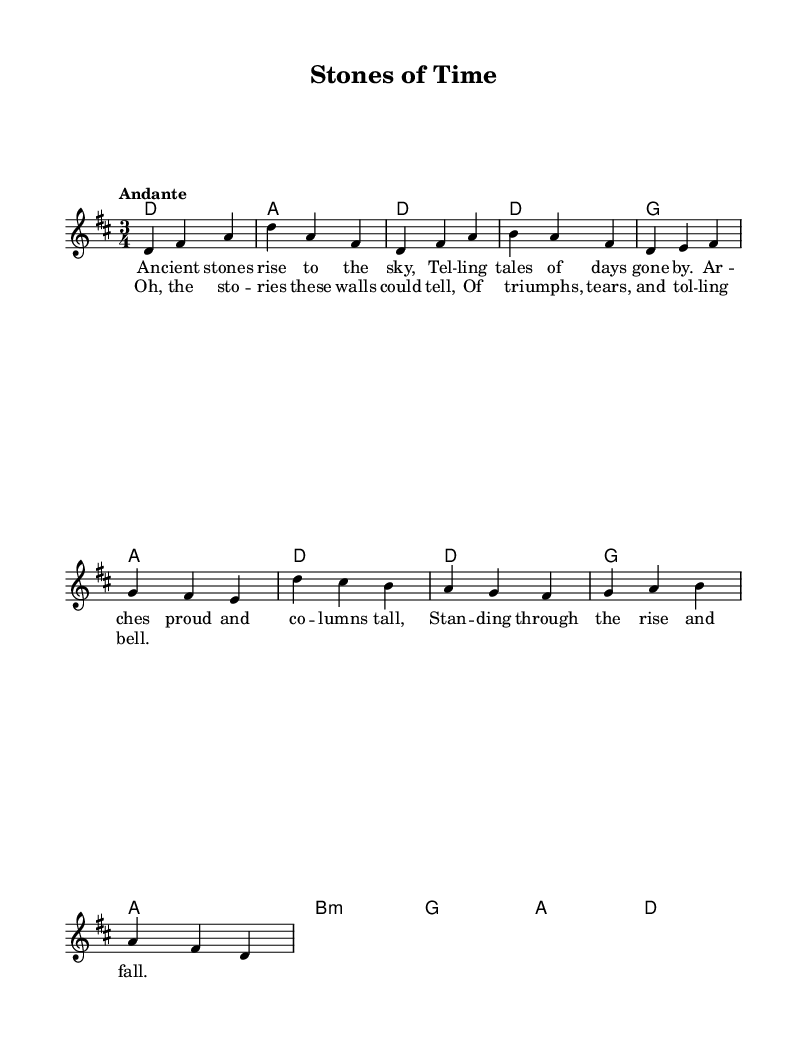What is the key signature of this music? The key signature is D major, which has two sharps (F# and C#). This can be determined by looking at the key signature indicated at the beginning of the staff in the sheet music.
Answer: D major What is the time signature of this music? The time signature indicated at the beginning is 3/4, which means there are three beats per measure and a quarter note gets one beat. This is visible immediately after the key signature at the start of the piece.
Answer: 3/4 What is the tempo marking for this piece? The tempo marking is "Andante," indicating a moderately slow tempo. This is noted at the start of the sheet music above the staff.
Answer: Andante How many measures are in the chorus section? The chorus section consists of four measures as indicated by the division of music in the sheet. Each line in the sheet music represents a measure, and when counting the measures in the chorus lyrics, there are four.
Answer: 4 What is the primary theme of the lyrics, based on the first verse? The primary theme of the lyrics in the first verse revolves around ancient stones and their historical significance, conveying a sense of timelessness and memory as described in the lyrics. By analyzing the content of the verse, the focus on history and nature of the stones is evident.
Answer: History What musical feature is highlighted in the chorus?' The musical feature highlighted in the chorus is the storytelling aspect represented by the lyrics. The phrase "Oh, the stories these walls could tell" directly connects to the theme conveyed throughout the verse, emphasizing narratives tied to the physical structure.
Answer: Storytelling Which chord is played after the first measure of the verse? The chord played after the first measure of the verse is G major. This follows directly from the chord progression indicated in the harmonies after the melody notes are established in the first measure of the verse.
Answer: G 